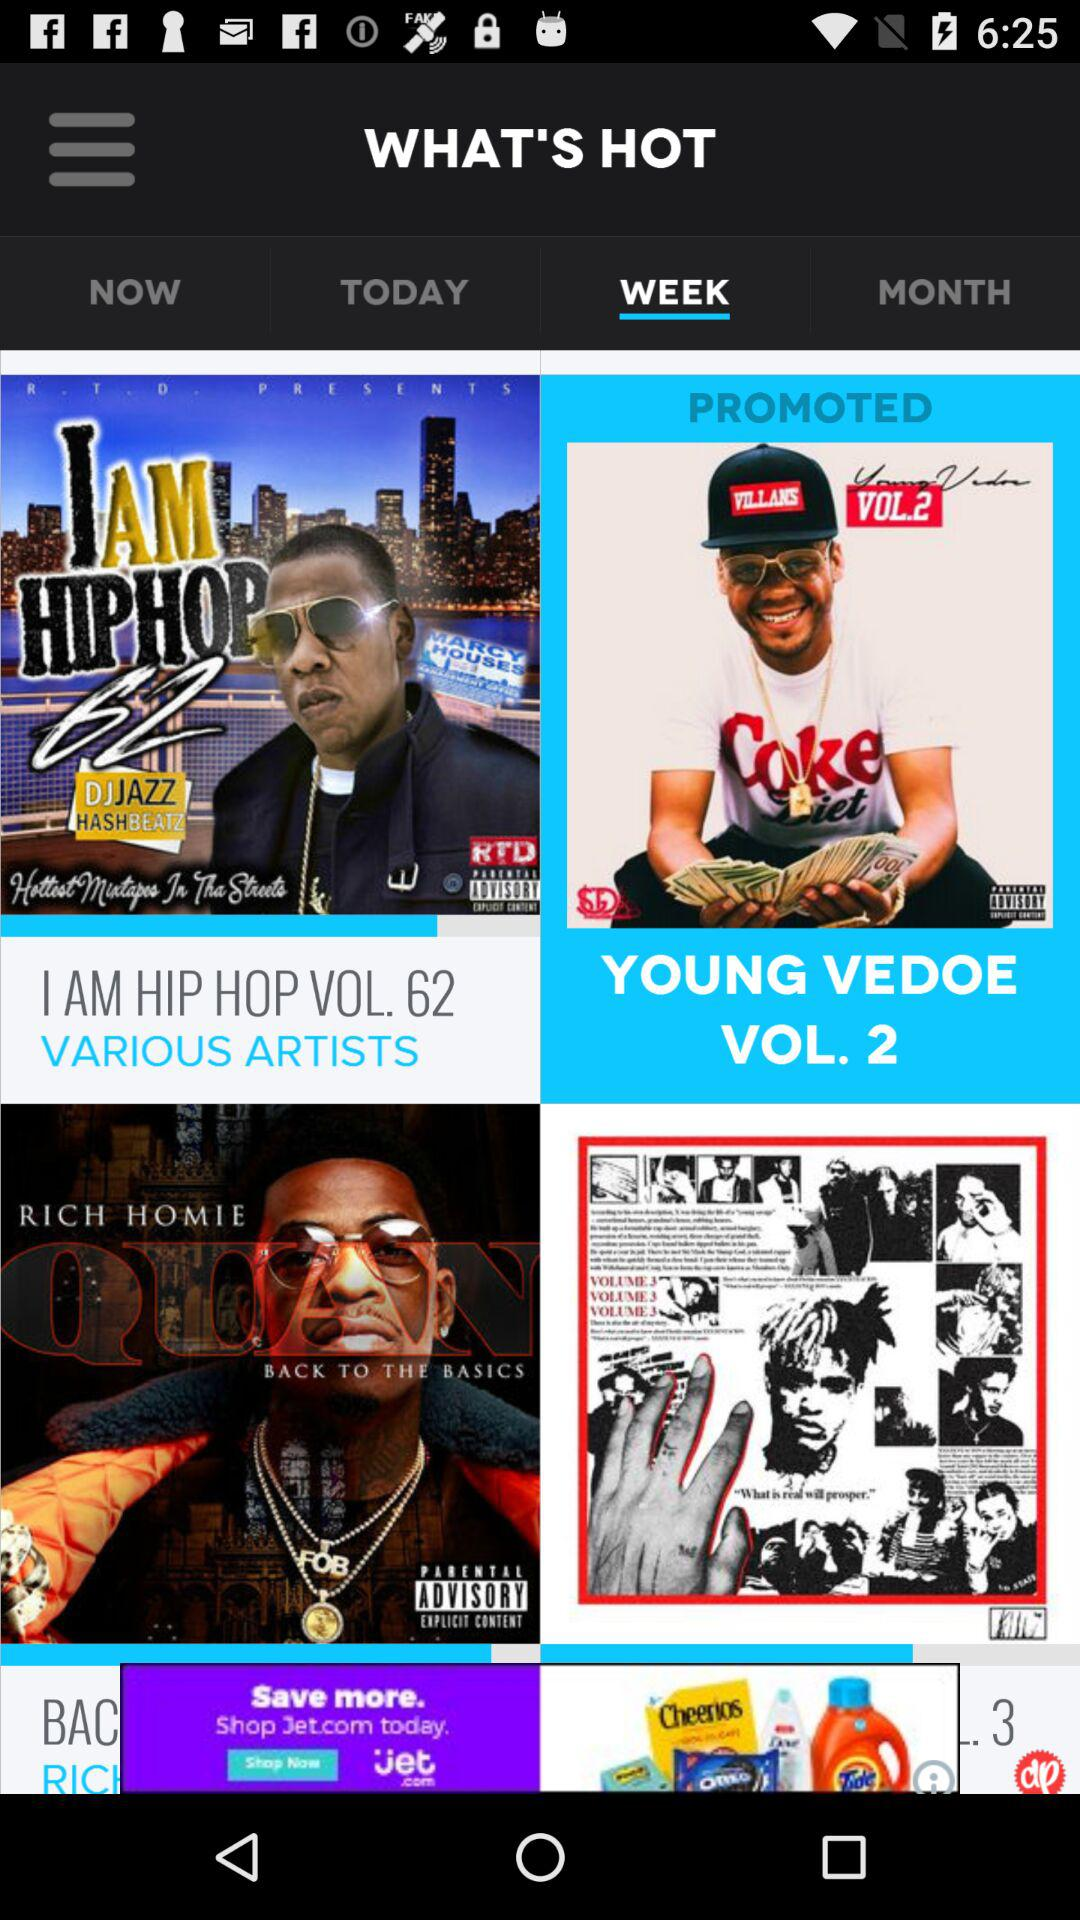Which volume is currently promoted by the Young Vedoe? The currently promoted volume is 2. 